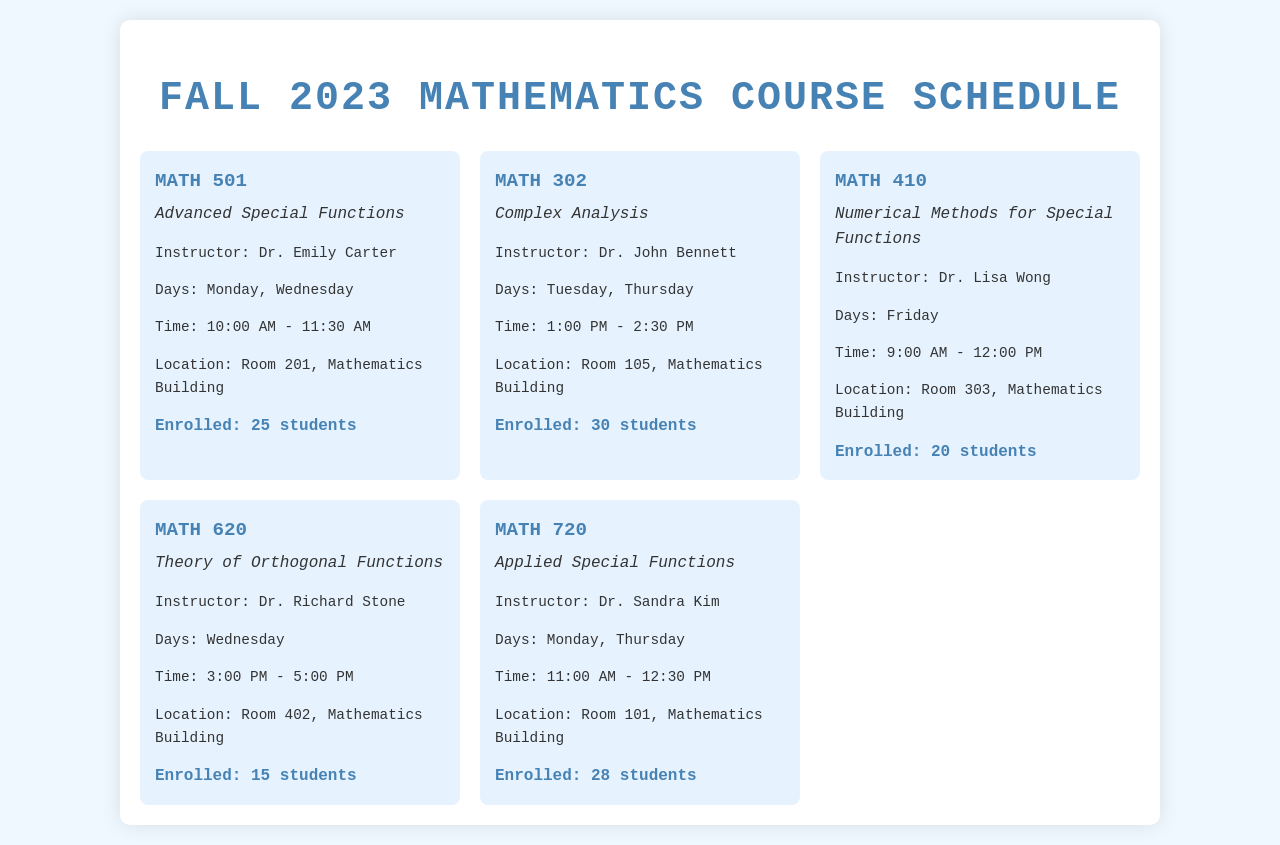What is the course code for Advanced Special Functions? The course code for Advanced Special Functions is listed prominently at the top of the course details.
Answer: MATH 501 Who is the instructor for Complex Analysis? The instructor's name is mentioned in the course details section for Complex Analysis.
Answer: Dr. John Bennett How many students are enrolled in Theory of Orthogonal Functions? The enrollment number is provided at the bottom of the course card for Theory of Orthogonal Functions.
Answer: 15 students What day is Numerical Methods for Special Functions taught? The specific day on which Numerical Methods for Special Functions is held is indicated in the course details.
Answer: Friday Which course is scheduled on Mondays? The courses that take place on Mondays can be deduced from the days listed in their details.
Answer: Advanced Special Functions, Applied Special Functions What time does the class for Applied Special Functions start? The starting time of the class is specified in the course details for Applied Special Functions.
Answer: 11:00 AM How many students are enrolled in MATH 410? The enrollment figure for MATH 410 is clearly mentioned below its course details.
Answer: 20 students What location is assigned for the course taught by Dr. Emily Carter? The location for each course is specified in its details, pointing to the right room.
Answer: Room 201, Mathematics Building 